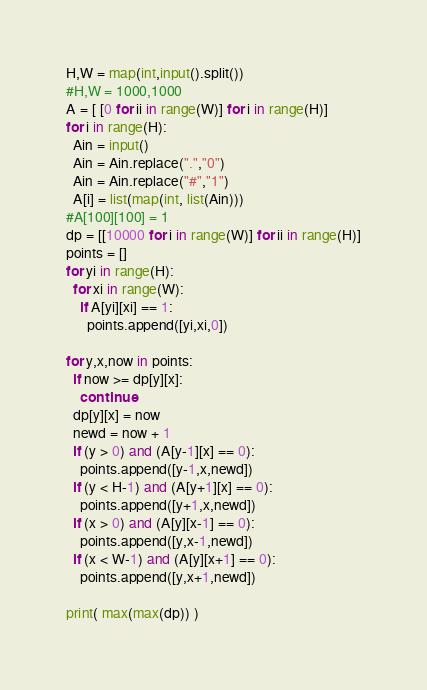<code> <loc_0><loc_0><loc_500><loc_500><_Python_>H,W = map(int,input().split())
#H,W = 1000,1000
A = [ [0 for ii in range(W)] for i in range(H)]
for i in range(H):
  Ain = input()
  Ain = Ain.replace(".","0")
  Ain = Ain.replace("#","1")
  A[i] = list(map(int, list(Ain)))
#A[100][100] = 1
dp = [[10000 for i in range(W)] for ii in range(H)]
points = []
for yi in range(H):
  for xi in range(W):
    if A[yi][xi] == 1:
      points.append([yi,xi,0])

for y,x,now in points:
  if now >= dp[y][x]:
    continue
  dp[y][x] = now
  newd = now + 1
  if (y > 0) and (A[y-1][x] == 0):
    points.append([y-1,x,newd])
  if (y < H-1) and (A[y+1][x] == 0):
    points.append([y+1,x,newd])
  if (x > 0) and (A[y][x-1] == 0):
    points.append([y,x-1,newd])
  if (x < W-1) and (A[y][x+1] == 0):
    points.append([y,x+1,newd])

print( max(max(dp)) )
</code> 